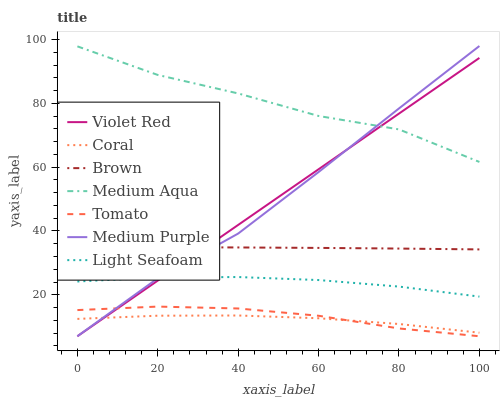Does Coral have the minimum area under the curve?
Answer yes or no. Yes. Does Medium Aqua have the maximum area under the curve?
Answer yes or no. Yes. Does Brown have the minimum area under the curve?
Answer yes or no. No. Does Brown have the maximum area under the curve?
Answer yes or no. No. Is Violet Red the smoothest?
Answer yes or no. Yes. Is Medium Aqua the roughest?
Answer yes or no. Yes. Is Brown the smoothest?
Answer yes or no. No. Is Brown the roughest?
Answer yes or no. No. Does Tomato have the lowest value?
Answer yes or no. Yes. Does Brown have the lowest value?
Answer yes or no. No. Does Medium Purple have the highest value?
Answer yes or no. Yes. Does Brown have the highest value?
Answer yes or no. No. Is Tomato less than Brown?
Answer yes or no. Yes. Is Light Seafoam greater than Coral?
Answer yes or no. Yes. Does Coral intersect Tomato?
Answer yes or no. Yes. Is Coral less than Tomato?
Answer yes or no. No. Is Coral greater than Tomato?
Answer yes or no. No. Does Tomato intersect Brown?
Answer yes or no. No. 